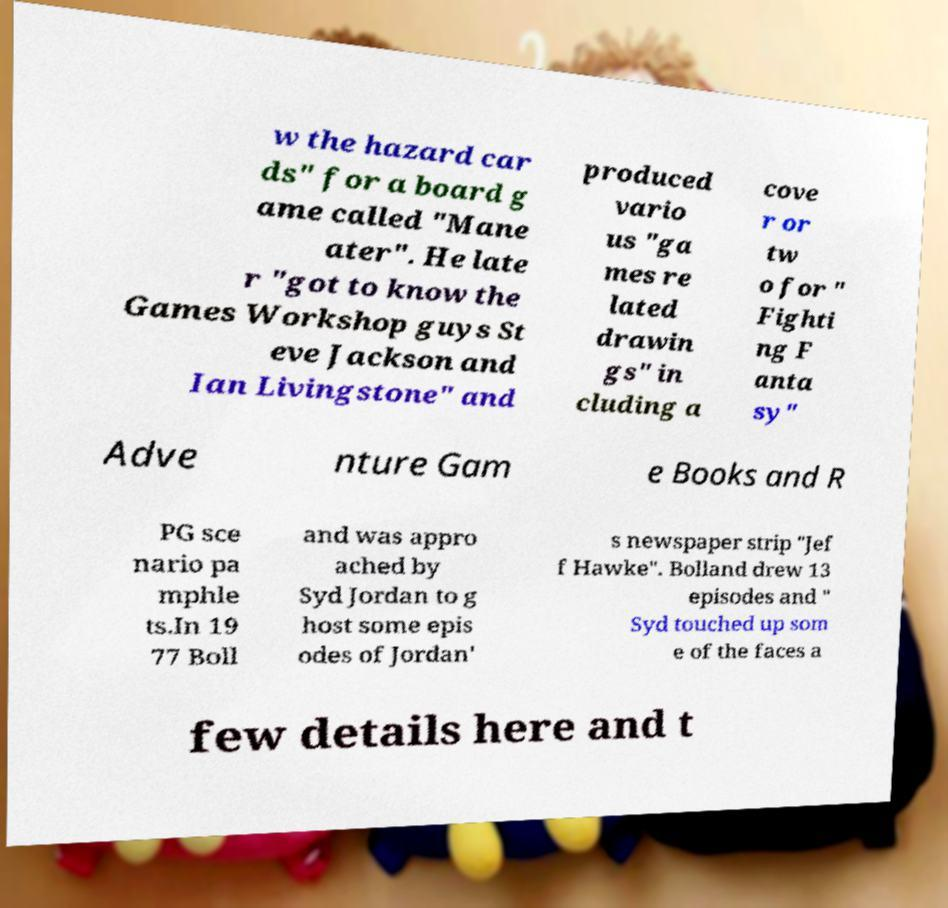Could you assist in decoding the text presented in this image and type it out clearly? w the hazard car ds" for a board g ame called "Mane ater". He late r "got to know the Games Workshop guys St eve Jackson and Ian Livingstone" and produced vario us "ga mes re lated drawin gs" in cluding a cove r or tw o for " Fighti ng F anta sy" Adve nture Gam e Books and R PG sce nario pa mphle ts.In 19 77 Boll and was appro ached by Syd Jordan to g host some epis odes of Jordan' s newspaper strip "Jef f Hawke". Bolland drew 13 episodes and " Syd touched up som e of the faces a few details here and t 